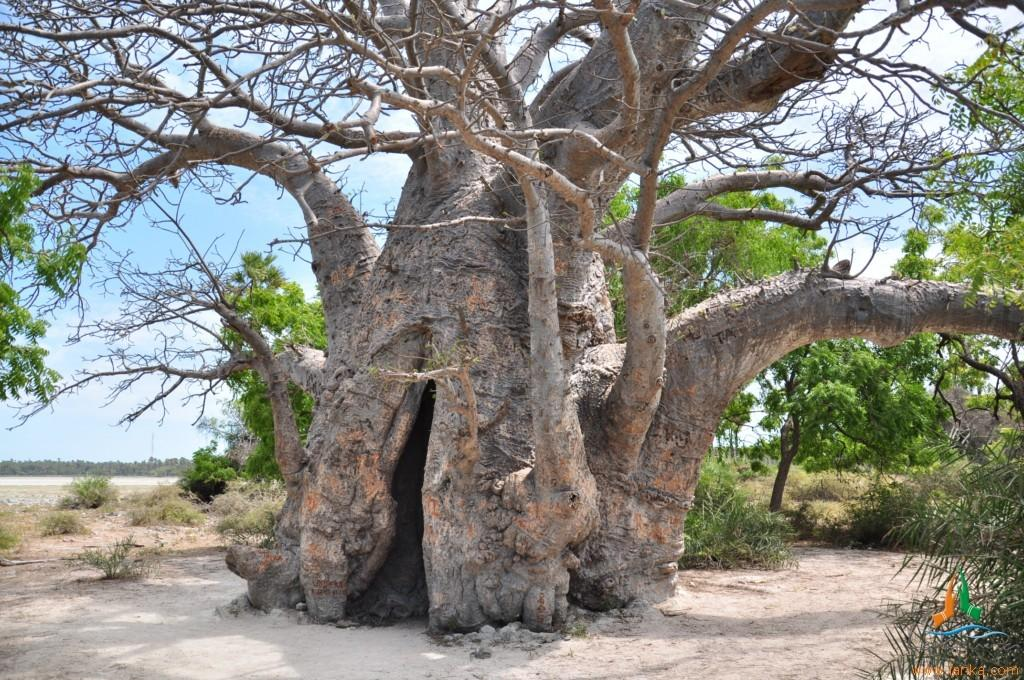Where was the picture taken? The picture was clicked outside. What is the main subject in the center of the image? There is a tree trunk and branches in the center of the image. What type of vegetation can be seen in the image? There are plants visible in the image. What is the ground covered with in the image? There is grass in the image. What can be seen in the background of the image? The sky is visible in the background of the image. What scent can be detected from the plants in the image? The image does not provide information about the scent of the plants, so it cannot be determined from the picture. 